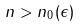<formula> <loc_0><loc_0><loc_500><loc_500>n > n _ { 0 } ( \epsilon )</formula> 